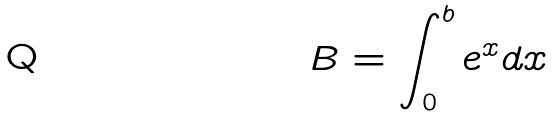<formula> <loc_0><loc_0><loc_500><loc_500>B = \int _ { 0 } ^ { b } e ^ { x } d x</formula> 